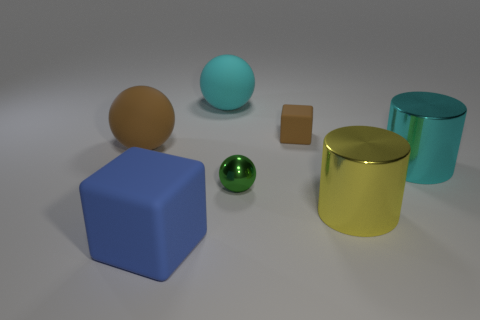Subtract all cyan balls. How many balls are left? 2 Add 2 large red shiny objects. How many objects exist? 9 Subtract 1 spheres. How many spheres are left? 2 Subtract all blue blocks. How many blocks are left? 1 Subtract all cylinders. How many objects are left? 5 Subtract all purple spheres. Subtract all blue cylinders. How many spheres are left? 3 Subtract all large yellow shiny cylinders. Subtract all large metallic cylinders. How many objects are left? 4 Add 3 brown things. How many brown things are left? 5 Add 4 yellow blocks. How many yellow blocks exist? 4 Subtract 0 brown cylinders. How many objects are left? 7 